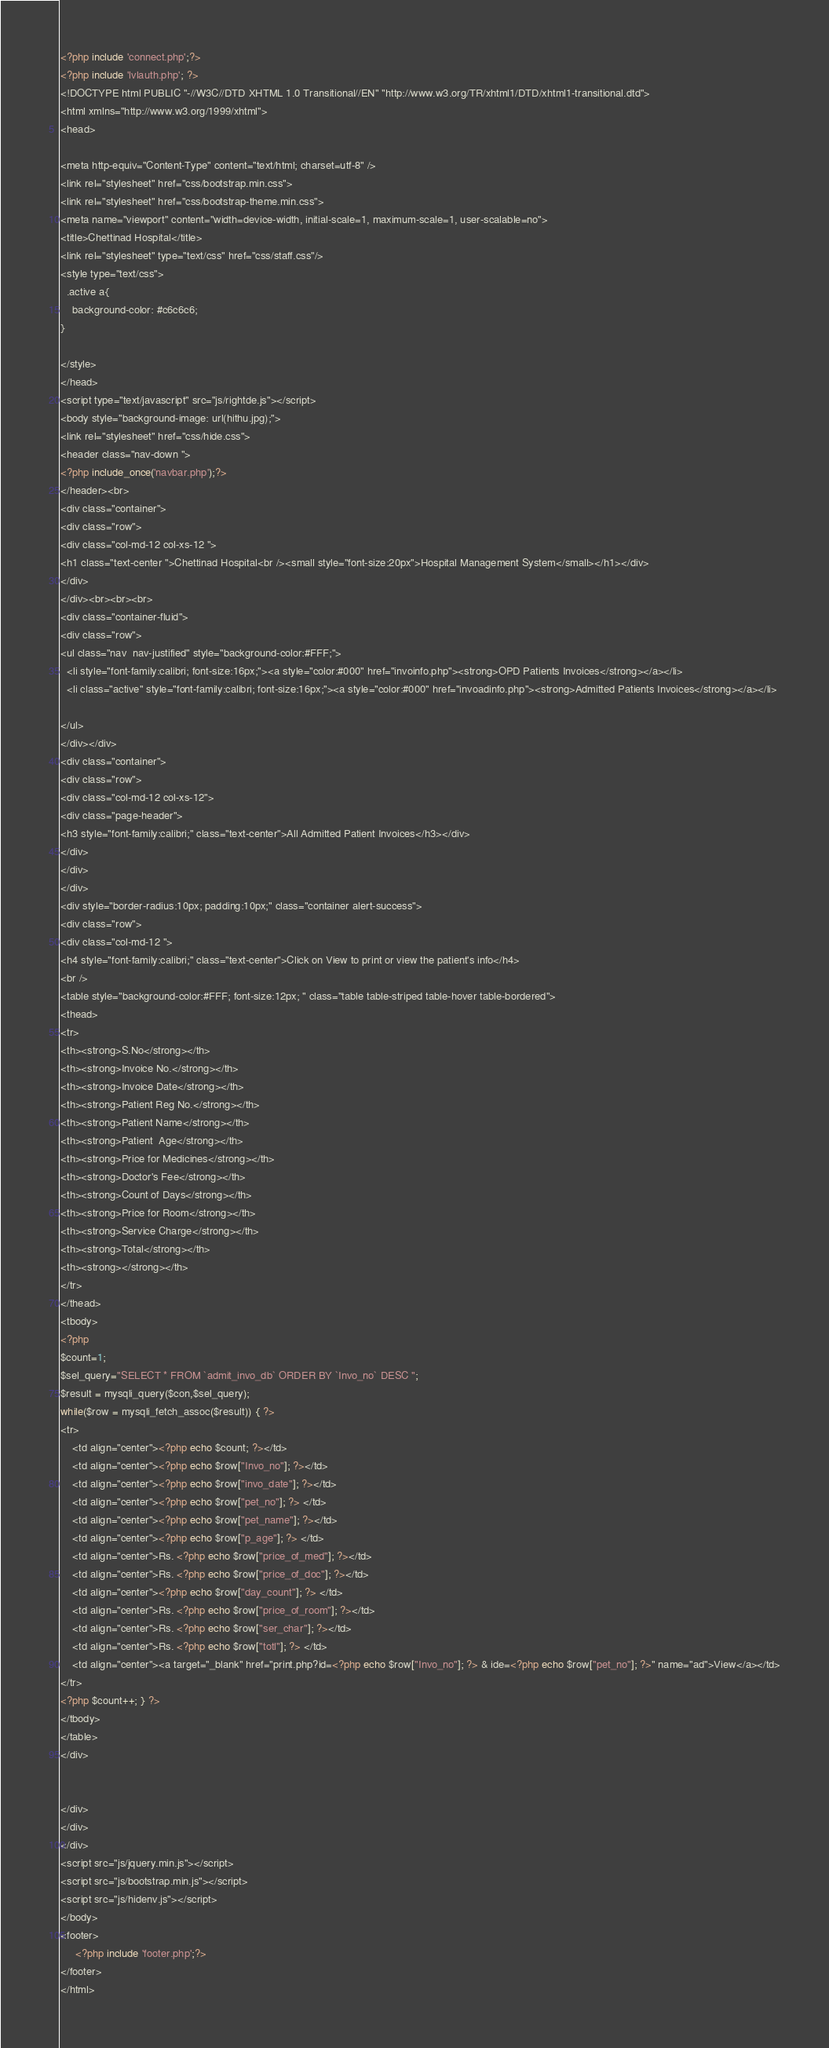<code> <loc_0><loc_0><loc_500><loc_500><_PHP_>
<?php include 'connect.php';?>
<?php include 'lvlauth.php'; ?>
<!DOCTYPE html PUBLIC "-//W3C//DTD XHTML 1.0 Transitional//EN" "http://www.w3.org/TR/xhtml1/DTD/xhtml1-transitional.dtd">
<html xmlns="http://www.w3.org/1999/xhtml">
<head>

<meta http-equiv="Content-Type" content="text/html; charset=utf-8" />
<link rel="stylesheet" href="css/bootstrap.min.css">
<link rel="stylesheet" href="css/bootstrap-theme.min.css">
<meta name="viewport" content="width=device-width, initial-scale=1, maximum-scale=1, user-scalable=no">
<title>Chettinad Hospital</title>
<link rel="stylesheet" type="text/css" href="css/staff.css"/>
<style type="text/css">
  .active a{
    background-color: #c6c6c6;
}

</style>
</head>
<script type="text/javascript" src="js/rightde.js"></script>
<body style="background-image: url(hithu.jpg);">
<link rel="stylesheet" href="css/hide.css">
<header class="nav-down ">
<?php include_once('navbar.php');?>
</header><br>
<div class="container">
<div class="row">
<div class="col-md-12 col-xs-12 ">
<h1 class="text-center ">Chettinad Hospital<br /><small style="font-size:20px">Hospital Management System</small></h1></div>
</div>
</div><br><br><br>
<div class="container-fluid">
<div class="row">
<ul class="nav  nav-justified" style="background-color:#FFF;">
  <li style="font-family:calibri; font-size:16px;"><a style="color:#000" href="invoinfo.php"><strong>OPD Patients Invoices</strong></a></li>
  <li class="active" style="font-family:calibri; font-size:16px;"><a style="color:#000" href="invoadinfo.php"><strong>Admitted Patients Invoices</strong></a></li>

</ul>
</div></div>
<div class="container">
<div class="row">
<div class="col-md-12 col-xs-12">
<div class="page-header">
<h3 style="font-family:calibri;" class="text-center">All Admitted Patient Invoices</h3></div>
</div>
</div>
</div>
<div style="border-radius:10px; padding:10px;" class="container alert-success">
<div class="row">
<div class="col-md-12 ">
<h4 style="font-family:calibri;" class="text-center">Click on View to print or view the patient's info</h4>
<br />
<table style="background-color:#FFF; font-size:12px; " class="table table-striped table-hover table-bordered">
<thead>
<tr>
<th><strong>S.No</strong></th>
<th><strong>Invoice No.</strong></th>
<th><strong>Invoice Date</strong></th>
<th><strong>Patient Reg No.</strong></th>
<th><strong>Patient Name</strong></th>
<th><strong>Patient  Age</strong></th>
<th><strong>Price for Medicines</strong></th>
<th><strong>Doctor's Fee</strong></th>
<th><strong>Count of Days</strong></th>
<th><strong>Price for Room</strong></th>
<th><strong>Service Charge</strong></th>
<th><strong>Total</strong></th>
<th><strong></strong></th>
</tr>
</thead>
<tbody>
<?php
$count=1;
$sel_query="SELECT * FROM `admit_invo_db` ORDER BY `Invo_no` DESC ";
$result = mysqli_query($con,$sel_query);
while($row = mysqli_fetch_assoc($result)) { ?>
<tr>
    <td align="center"><?php echo $count; ?></td>
    <td align="center"><?php echo $row["Invo_no"]; ?></td>
    <td align="center"><?php echo $row["invo_date"]; ?></td>
    <td align="center"><?php echo $row["pet_no"]; ?> </td>
    <td align="center"><?php echo $row["pet_name"]; ?></td>
    <td align="center"><?php echo $row["p_age"]; ?> </td>
    <td align="center">Rs. <?php echo $row["price_of_med"]; ?></td>
    <td align="center">Rs. <?php echo $row["price_of_doc"]; ?></td>
    <td align="center"><?php echo $row["day_count"]; ?> </td>
    <td align="center">Rs. <?php echo $row["price_of_room"]; ?></td>
    <td align="center">Rs. <?php echo $row["ser_char"]; ?></td>
    <td align="center">Rs. <?php echo $row["totl"]; ?> </td>
    <td align="center"><a target="_blank" href="print.php?id=<?php echo $row["Invo_no"]; ?> & ide=<?php echo $row["pet_no"]; ?>" name="ad">View</a></td>
</tr>
<?php $count++; } ?>
</tbody>
</table>
</div>


</div>
</div>
</div>
<script src="js/jquery.min.js"></script>
<script src="js/bootstrap.min.js"></script>
<script src="js/hidenv.js"></script>
</body>
<footer>
	 <?php include 'footer.php';?>
</footer>
</html>
</code> 